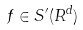<formula> <loc_0><loc_0><loc_500><loc_500>f \in S ^ { \prime } ( R ^ { d } )</formula> 